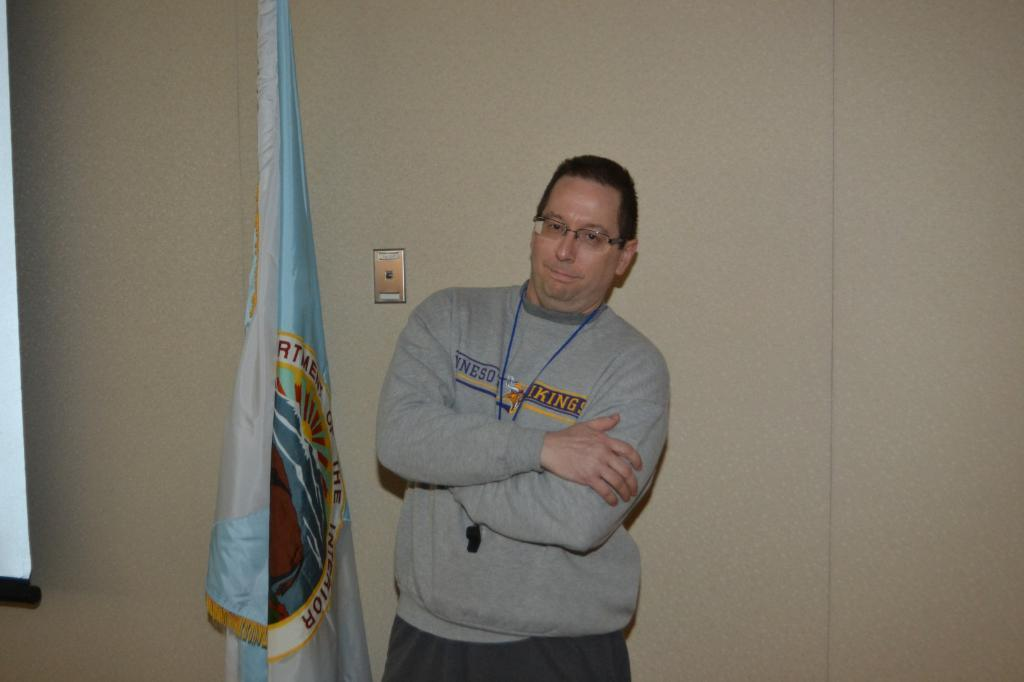What is the man doing in the image? The man is standing near the wall in the image. What can be seen around the man's neck? The man has a whistle around his neck. What type of eyewear is the man wearing? The man is wearing spectacles. What type of clothing is the man wearing on his upper body? The man is wearing a t-shirt. What is located beside the man in the image? There is a flag beside the man. What is visible in the background of the image? There is a wall in the background of the image. Reasoning: Let'ing: Let's think step by step in order to produce the conversation. We start by identifying the main subject in the image, which is the man standing near the wall. Then, we expand the conversation to include other details about the man, such as the whistle around his neck, his spectacles, and the t-shirt he is wearing. We also mention the flag beside him and the wall in the background. Each question is designed to elicit a specific detail about the image that is known from the provided facts. Absurd Question/Answer: What time is displayed on the clock hanging on the wall in the image? There is no clock present in the image; only a wall can be seen in the background. 